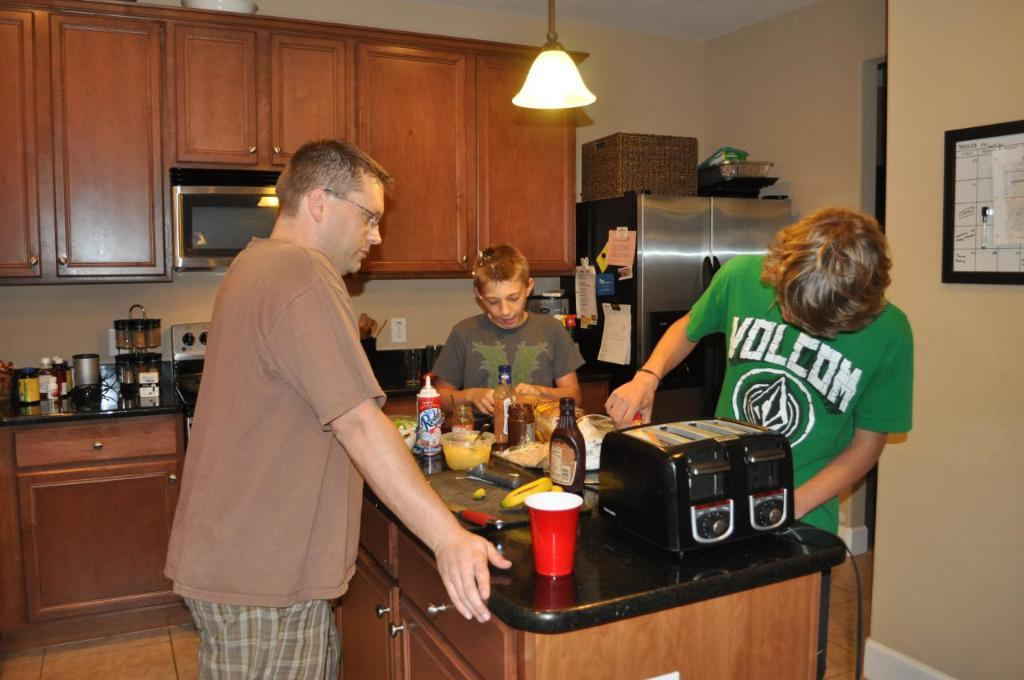<image>
Describe the image concisely. A young man in a green Volcom t-shirt is in the kitchen. 